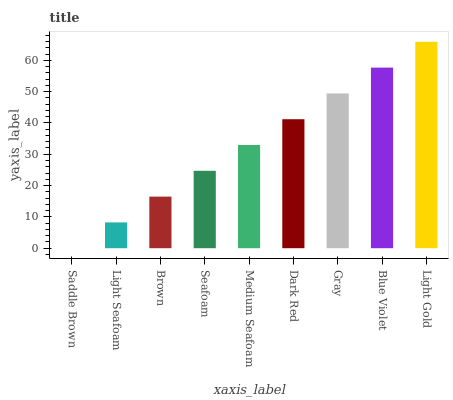Is Saddle Brown the minimum?
Answer yes or no. Yes. Is Light Gold the maximum?
Answer yes or no. Yes. Is Light Seafoam the minimum?
Answer yes or no. No. Is Light Seafoam the maximum?
Answer yes or no. No. Is Light Seafoam greater than Saddle Brown?
Answer yes or no. Yes. Is Saddle Brown less than Light Seafoam?
Answer yes or no. Yes. Is Saddle Brown greater than Light Seafoam?
Answer yes or no. No. Is Light Seafoam less than Saddle Brown?
Answer yes or no. No. Is Medium Seafoam the high median?
Answer yes or no. Yes. Is Medium Seafoam the low median?
Answer yes or no. Yes. Is Dark Red the high median?
Answer yes or no. No. Is Dark Red the low median?
Answer yes or no. No. 